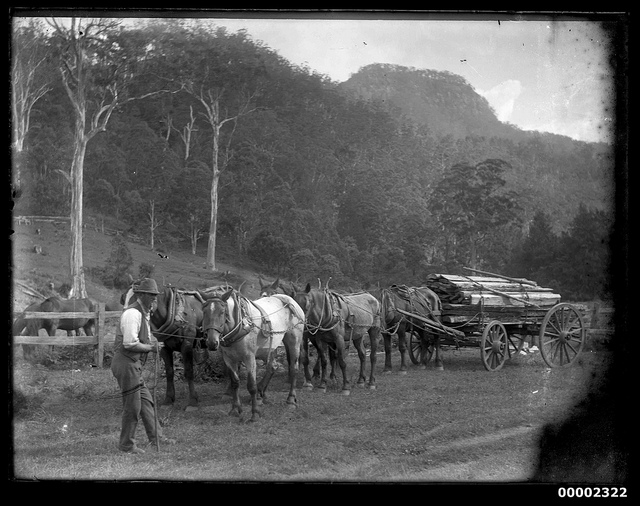Read and extract the text from this image. 00002322 